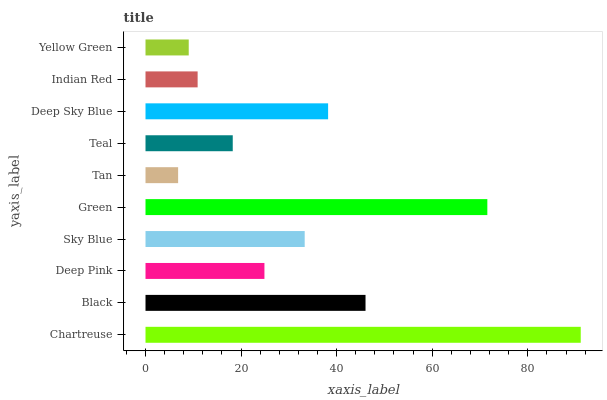Is Tan the minimum?
Answer yes or no. Yes. Is Chartreuse the maximum?
Answer yes or no. Yes. Is Black the minimum?
Answer yes or no. No. Is Black the maximum?
Answer yes or no. No. Is Chartreuse greater than Black?
Answer yes or no. Yes. Is Black less than Chartreuse?
Answer yes or no. Yes. Is Black greater than Chartreuse?
Answer yes or no. No. Is Chartreuse less than Black?
Answer yes or no. No. Is Sky Blue the high median?
Answer yes or no. Yes. Is Deep Pink the low median?
Answer yes or no. Yes. Is Deep Pink the high median?
Answer yes or no. No. Is Black the low median?
Answer yes or no. No. 